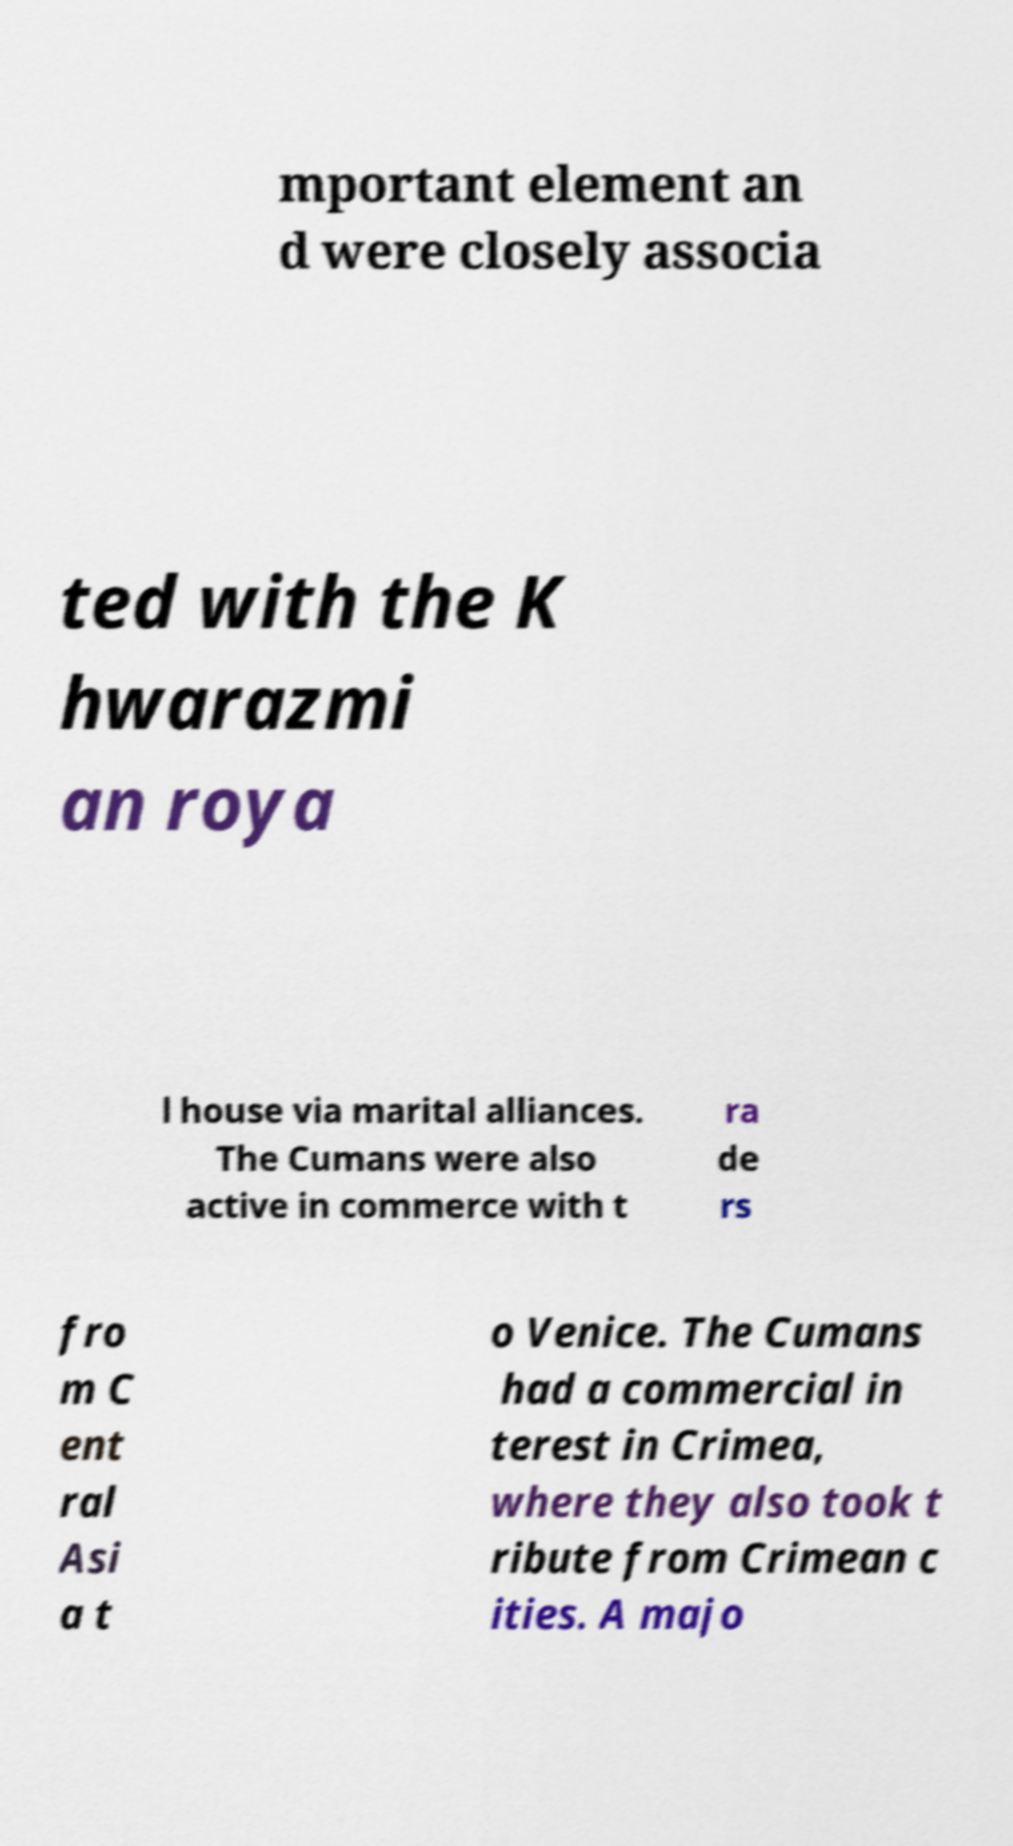Can you accurately transcribe the text from the provided image for me? mportant element an d were closely associa ted with the K hwarazmi an roya l house via marital alliances. The Cumans were also active in commerce with t ra de rs fro m C ent ral Asi a t o Venice. The Cumans had a commercial in terest in Crimea, where they also took t ribute from Crimean c ities. A majo 